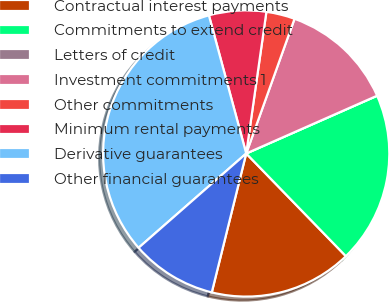Convert chart to OTSL. <chart><loc_0><loc_0><loc_500><loc_500><pie_chart><fcel>Contractual interest payments<fcel>Commitments to extend credit<fcel>Letters of credit<fcel>Investment commitments 1<fcel>Other commitments<fcel>Minimum rental payments<fcel>Derivative guarantees<fcel>Other financial guarantees<nl><fcel>16.13%<fcel>19.35%<fcel>0.0%<fcel>12.9%<fcel>3.23%<fcel>6.45%<fcel>32.25%<fcel>9.68%<nl></chart> 